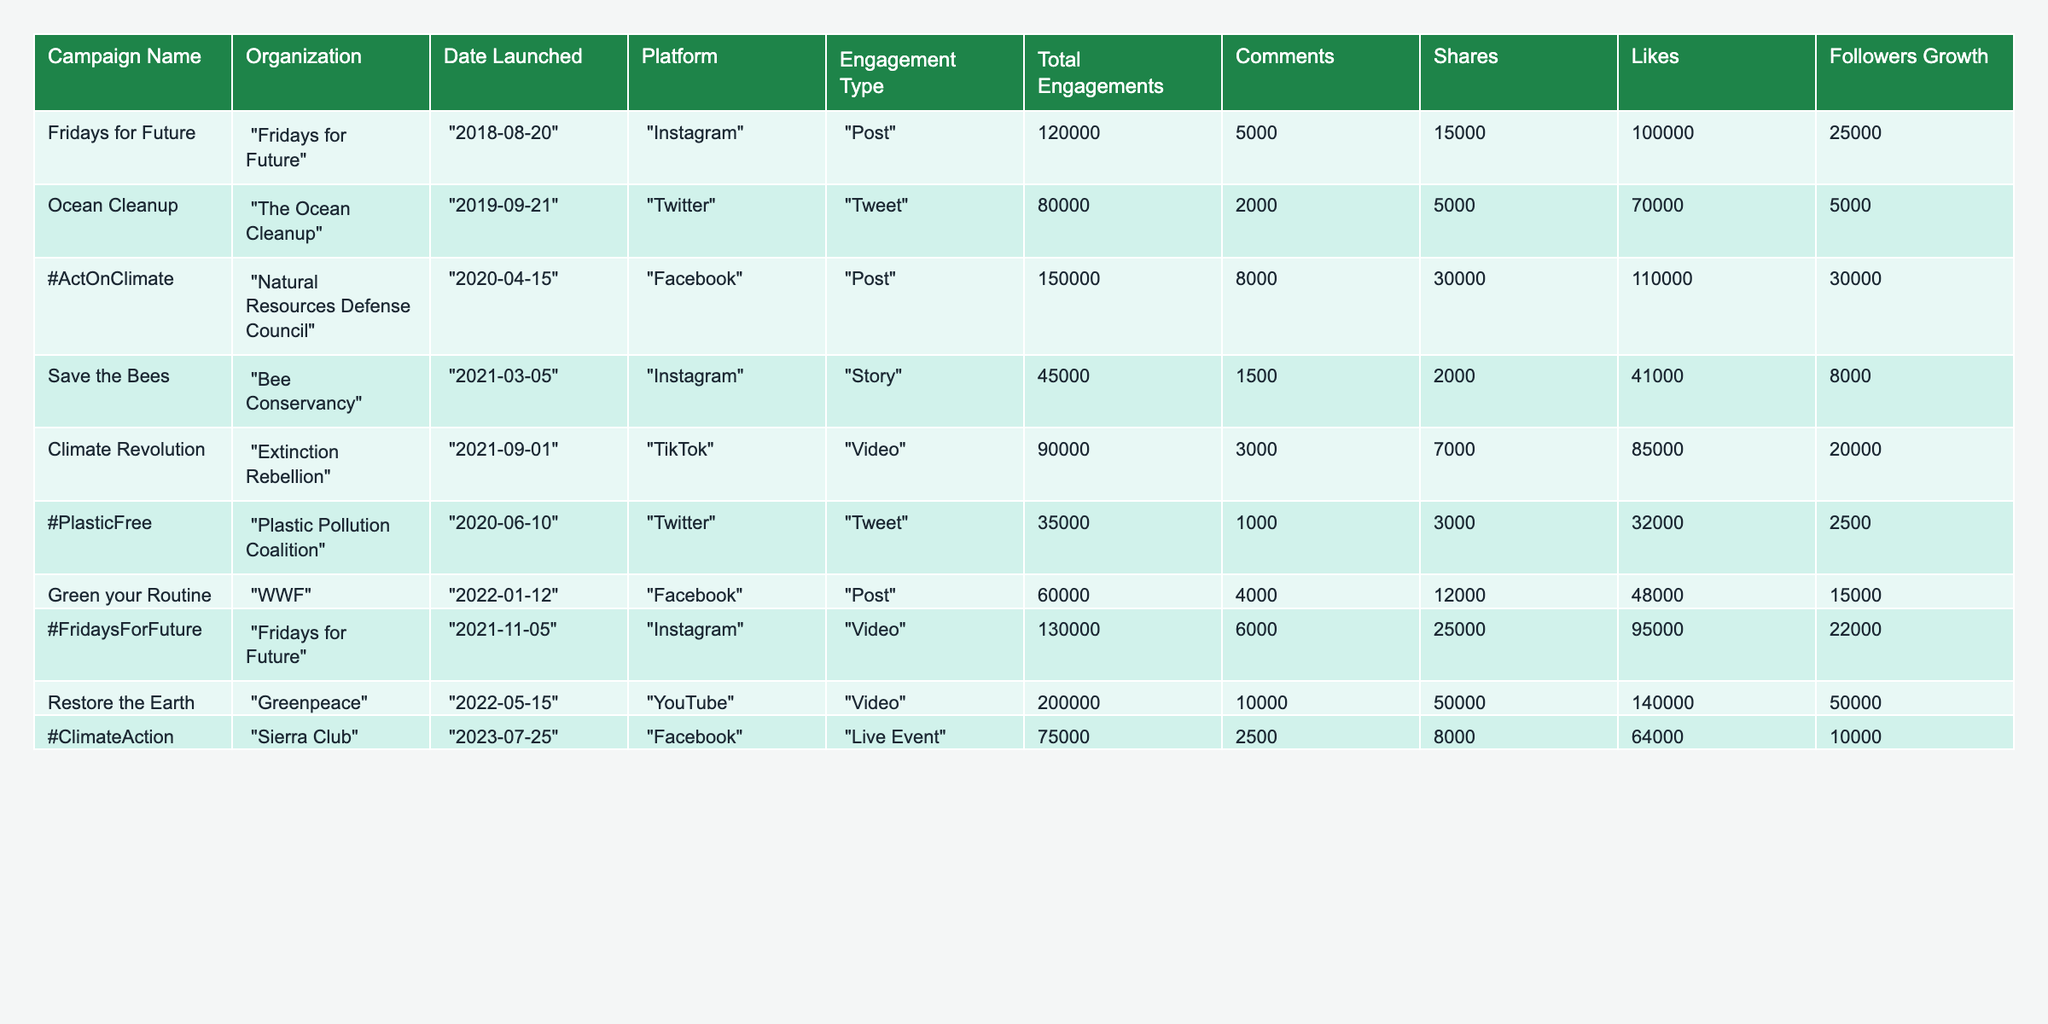What is the total number of engagements for the "Restore the Earth" campaign? The total engagements for the "Restore the Earth" campaign, as listed in the table, is specifically stated as 200000.
Answer: 200000 Which campaign had the highest number of likes, and how many likes did it receive? By checking the likes for each campaign in the table, "Restore the Earth" received the highest number at 140000 likes.
Answer: "Restore the Earth", 140000 What is the engagement type for the "Green your Routine" campaign? The table specifies that the engagement type for the "Green your Routine" campaign is "Post".
Answer: Post How many campaigns had their total engagements exceed 100,000? Reviewing each campaign's total engagements in the table, we find that "Fridays for Future", "#ActOnClimate", "#FridaysForFuture", and "Restore the Earth" exceed 100,000, making a total of 4 campaigns.
Answer: 4 Calculate the average followers growth for all campaigns. Adding the followers growth values: 25000 + 5000 + 30000 + 8000 + 20000 + 2500 + 15000 + 22000 + 50000 = 107500. There are 9 campaigns, so the average is 107500/9 = approximately 11944.4.
Answer: 11944.4 Which platform had the most campaigns represented in the table? By counting the entries in each platform, we see: Instagram (3), Twitter (2), Facebook (3), TikTok (1), YouTube (1). Instagram and Facebook each have 3 campaigns, so they tie for the most represented platform.
Answer: Instagram and Facebook Is the total engagements for the "#PlasticFree" campaign higher than the total engagements for the "Save the Bees" campaign? Comparing total engagements, "#PlasticFree" has 35000 while "Save the Bees" has 45000. Since 35000 is less than 45000, the statement is false.
Answer: No What is the difference in total engagements between the "Ocean Cleanup" campaign and the "#ClimateAction" campaign? The "Ocean Cleanup" campaign has 80000 engagements, while the "#ClimateAction" campaign has 75000. The difference is 80000 - 75000 = 5000.
Answer: 5000 What is the sum of comments from all campaigns? Summing comments: 5000 + 2000 + 8000 + 1500 + 3000 + 1000 + 4000 + 6000 + 2500 = 25000.
Answer: 25000 Which campaign experienced the largest growth in followers, and what was the amount? After reviewing the followers growth for each campaign, "Restore the Earth" saw the highest increase at 50000 followers.
Answer: "Restore the Earth", 50000 